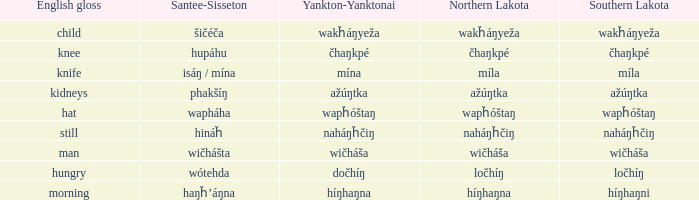What is the equivalent of híŋhaŋna in southern lakota language? Híŋhaŋni. 